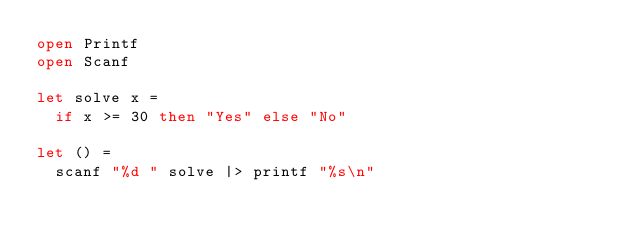<code> <loc_0><loc_0><loc_500><loc_500><_OCaml_>open Printf
open Scanf

let solve x =
  if x >= 30 then "Yes" else "No"

let () =
  scanf "%d " solve |> printf "%s\n"
</code> 